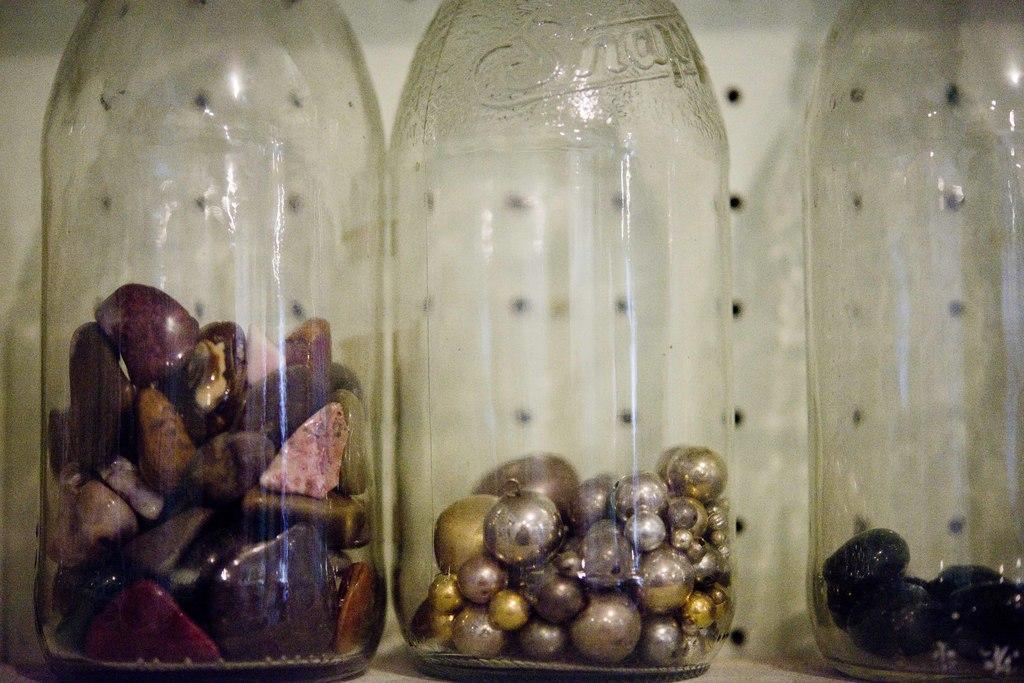<image>
Share a concise interpretation of the image provided. An empty Snapple bottle now contains metallic beads instead of a drink. 